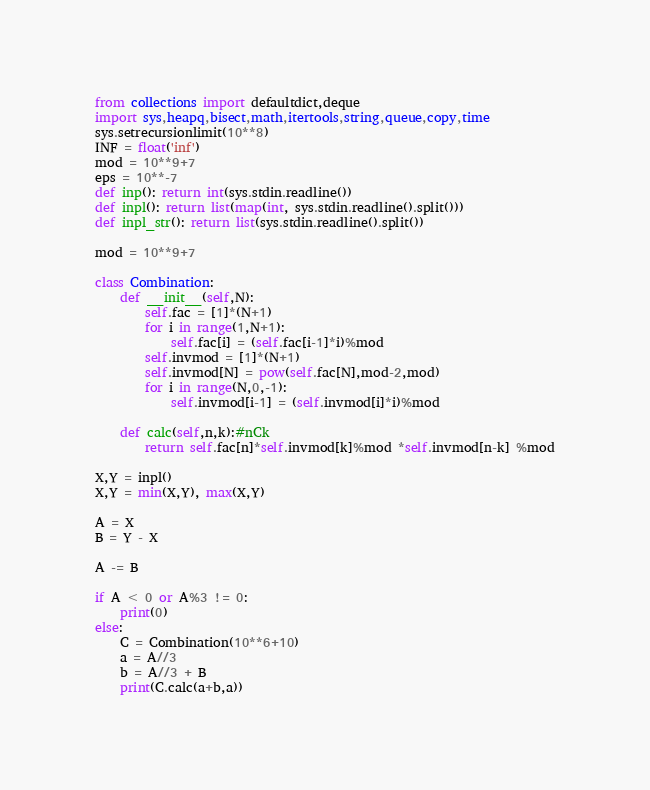Convert code to text. <code><loc_0><loc_0><loc_500><loc_500><_Python_>
from collections import defaultdict,deque
import sys,heapq,bisect,math,itertools,string,queue,copy,time
sys.setrecursionlimit(10**8)
INF = float('inf')
mod = 10**9+7
eps = 10**-7
def inp(): return int(sys.stdin.readline())
def inpl(): return list(map(int, sys.stdin.readline().split()))
def inpl_str(): return list(sys.stdin.readline().split())

mod = 10**9+7

class Combination:
    def __init__(self,N):
        self.fac = [1]*(N+1)
        for i in range(1,N+1):
            self.fac[i] = (self.fac[i-1]*i)%mod
        self.invmod = [1]*(N+1)
        self.invmod[N] = pow(self.fac[N],mod-2,mod)
        for i in range(N,0,-1):
            self.invmod[i-1] = (self.invmod[i]*i)%mod

    def calc(self,n,k):#nCk
        return self.fac[n]*self.invmod[k]%mod *self.invmod[n-k] %mod

X,Y = inpl()
X,Y = min(X,Y), max(X,Y)

A = X
B = Y - X

A -= B

if A < 0 or A%3 != 0:
    print(0)
else:
    C = Combination(10**6+10)
    a = A//3
    b = A//3 + B
    print(C.calc(a+b,a))
</code> 